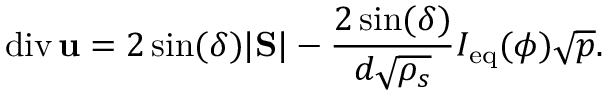<formula> <loc_0><loc_0><loc_500><loc_500>d i v \, { u } = 2 \sin ( \delta ) | S | - \frac { 2 \sin ( \delta ) } { d \sqrt { \rho _ { s } } } I _ { e q } ( \phi ) \sqrt { p } .</formula> 